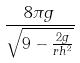<formula> <loc_0><loc_0><loc_500><loc_500>\frac { 8 \pi g } { \sqrt { 9 - \frac { 2 g } { r h ^ { 2 } } } }</formula> 